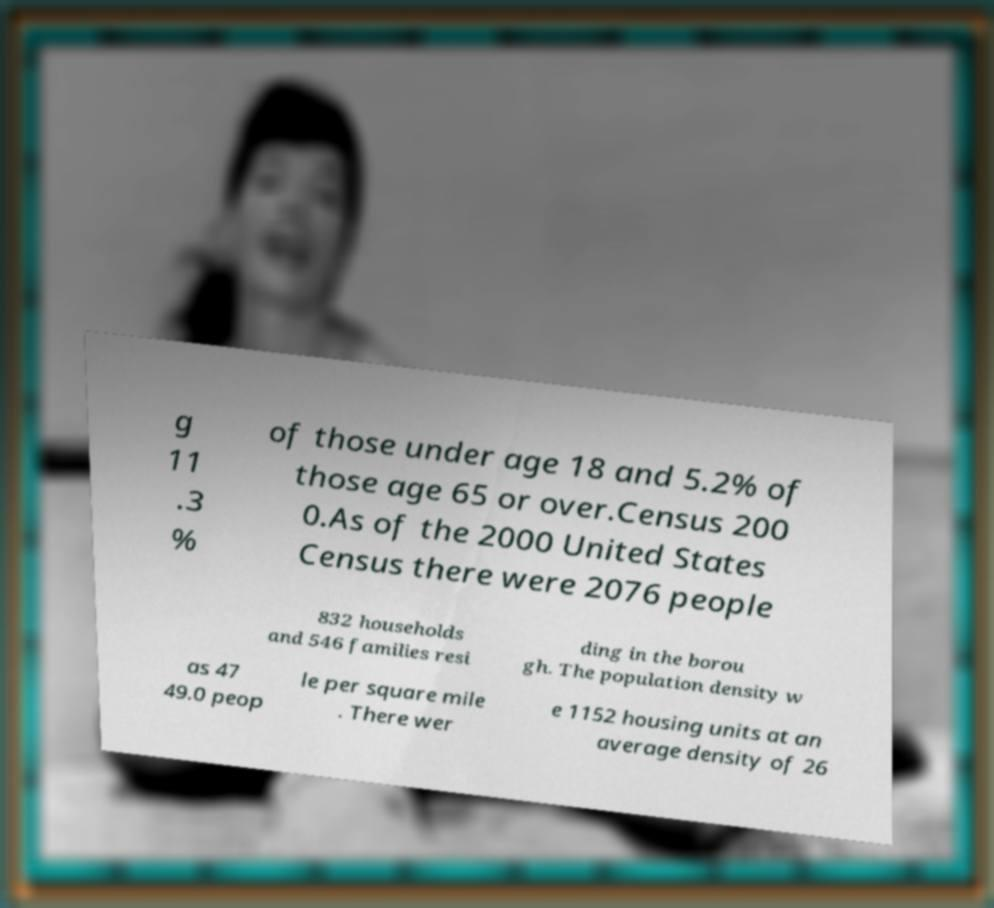Please read and relay the text visible in this image. What does it say? g 11 .3 % of those under age 18 and 5.2% of those age 65 or over.Census 200 0.As of the 2000 United States Census there were 2076 people 832 households and 546 families resi ding in the borou gh. The population density w as 47 49.0 peop le per square mile . There wer e 1152 housing units at an average density of 26 